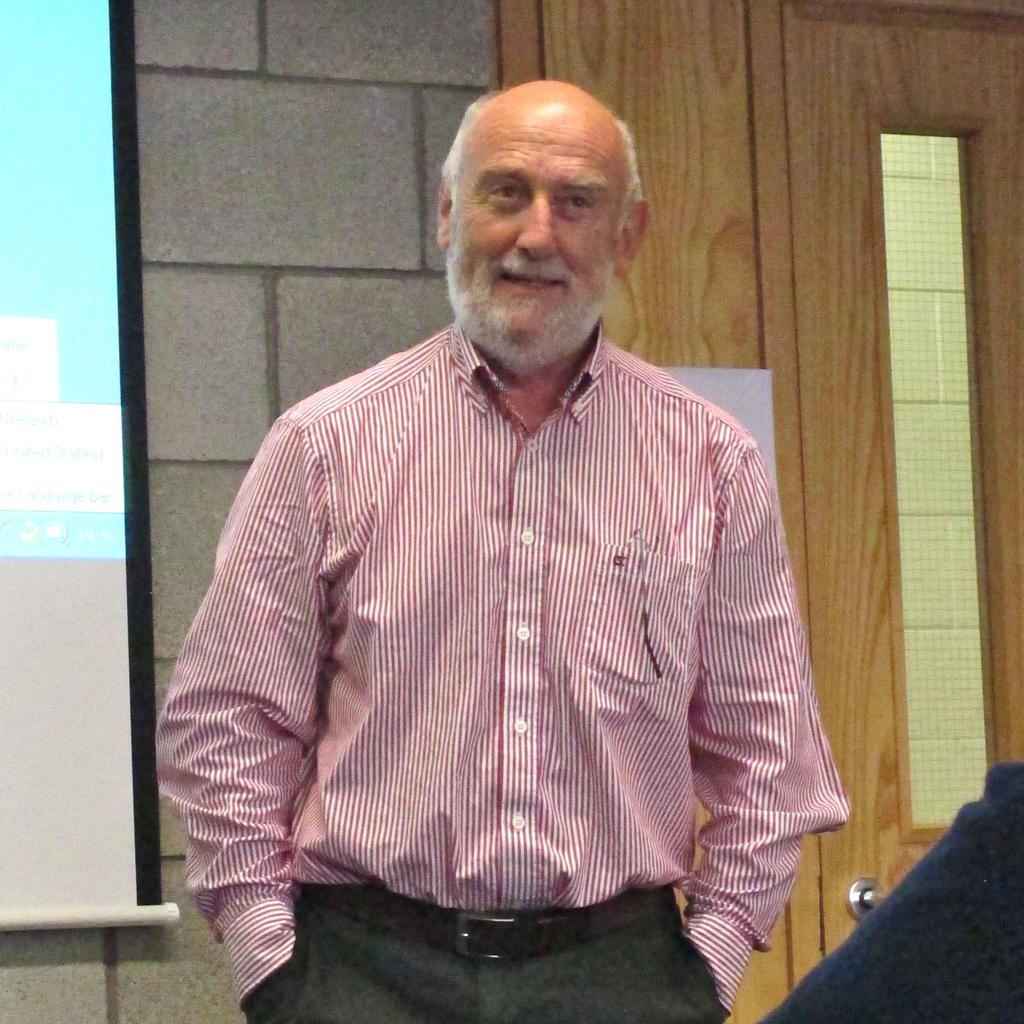What is the main subject of the image? There is a person standing in the image. Can you describe the person's attire? The person is wearing a pink and black color dress. What can be seen in the background of the image? There is a wall, a door, and a projection-screen in the background of the image. Can you tell me how many squirrels are sitting on the blade in the image? There are no squirrels or blades present in the image. 